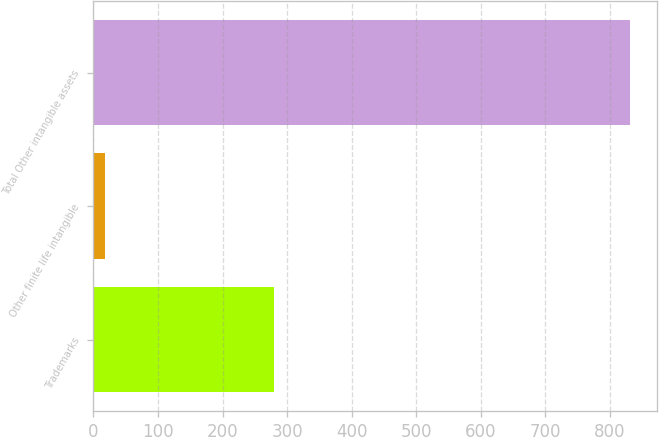Convert chart. <chart><loc_0><loc_0><loc_500><loc_500><bar_chart><fcel>Trademarks<fcel>Other finite life intangible<fcel>Total Other intangible assets<nl><fcel>279.5<fcel>18.5<fcel>831.1<nl></chart> 